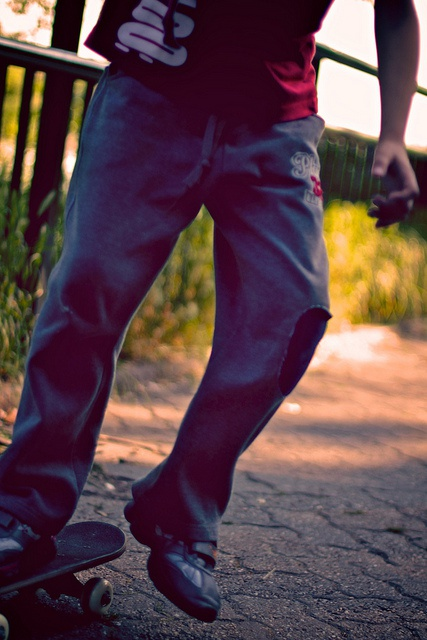Describe the objects in this image and their specific colors. I can see people in ivory, black, navy, gray, and darkblue tones and skateboard in ivory, black, gray, and blue tones in this image. 